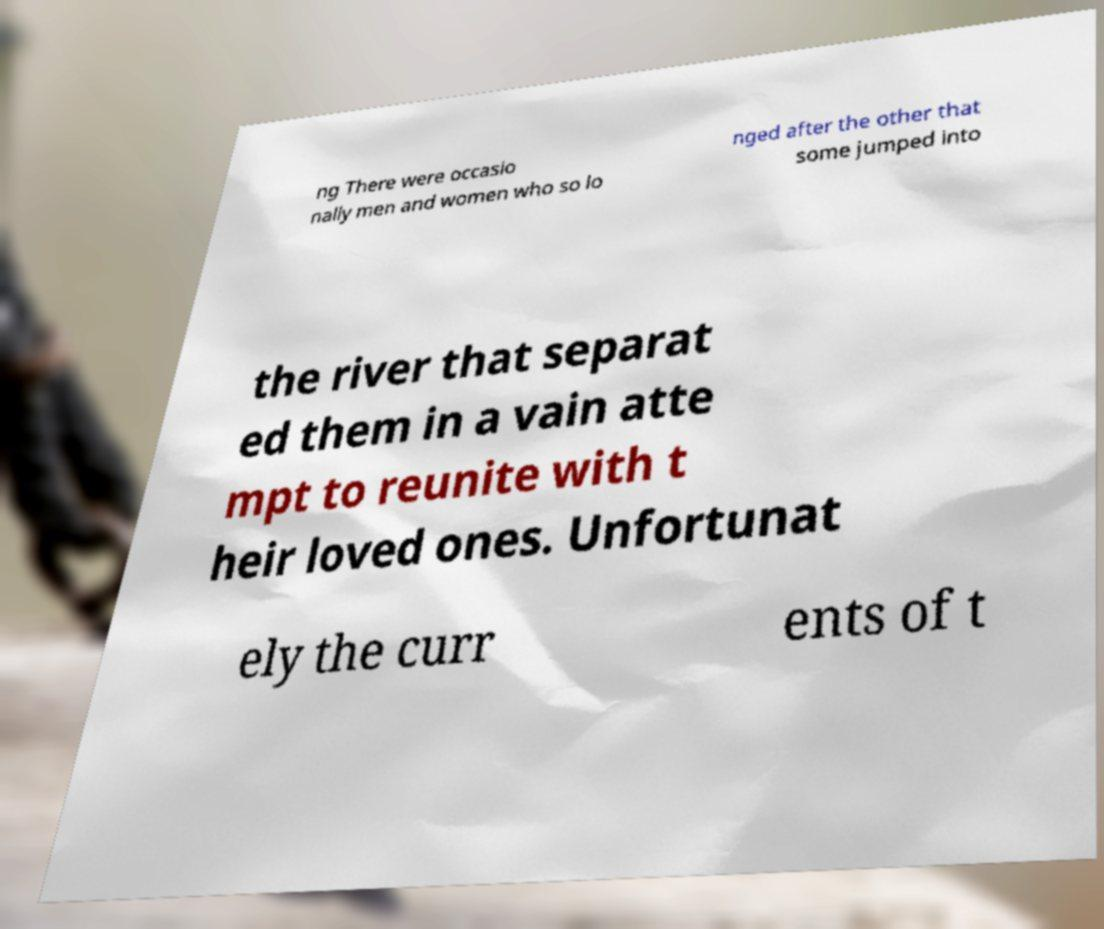Please identify and transcribe the text found in this image. ng There were occasio nally men and women who so lo nged after the other that some jumped into the river that separat ed them in a vain atte mpt to reunite with t heir loved ones. Unfortunat ely the curr ents of t 